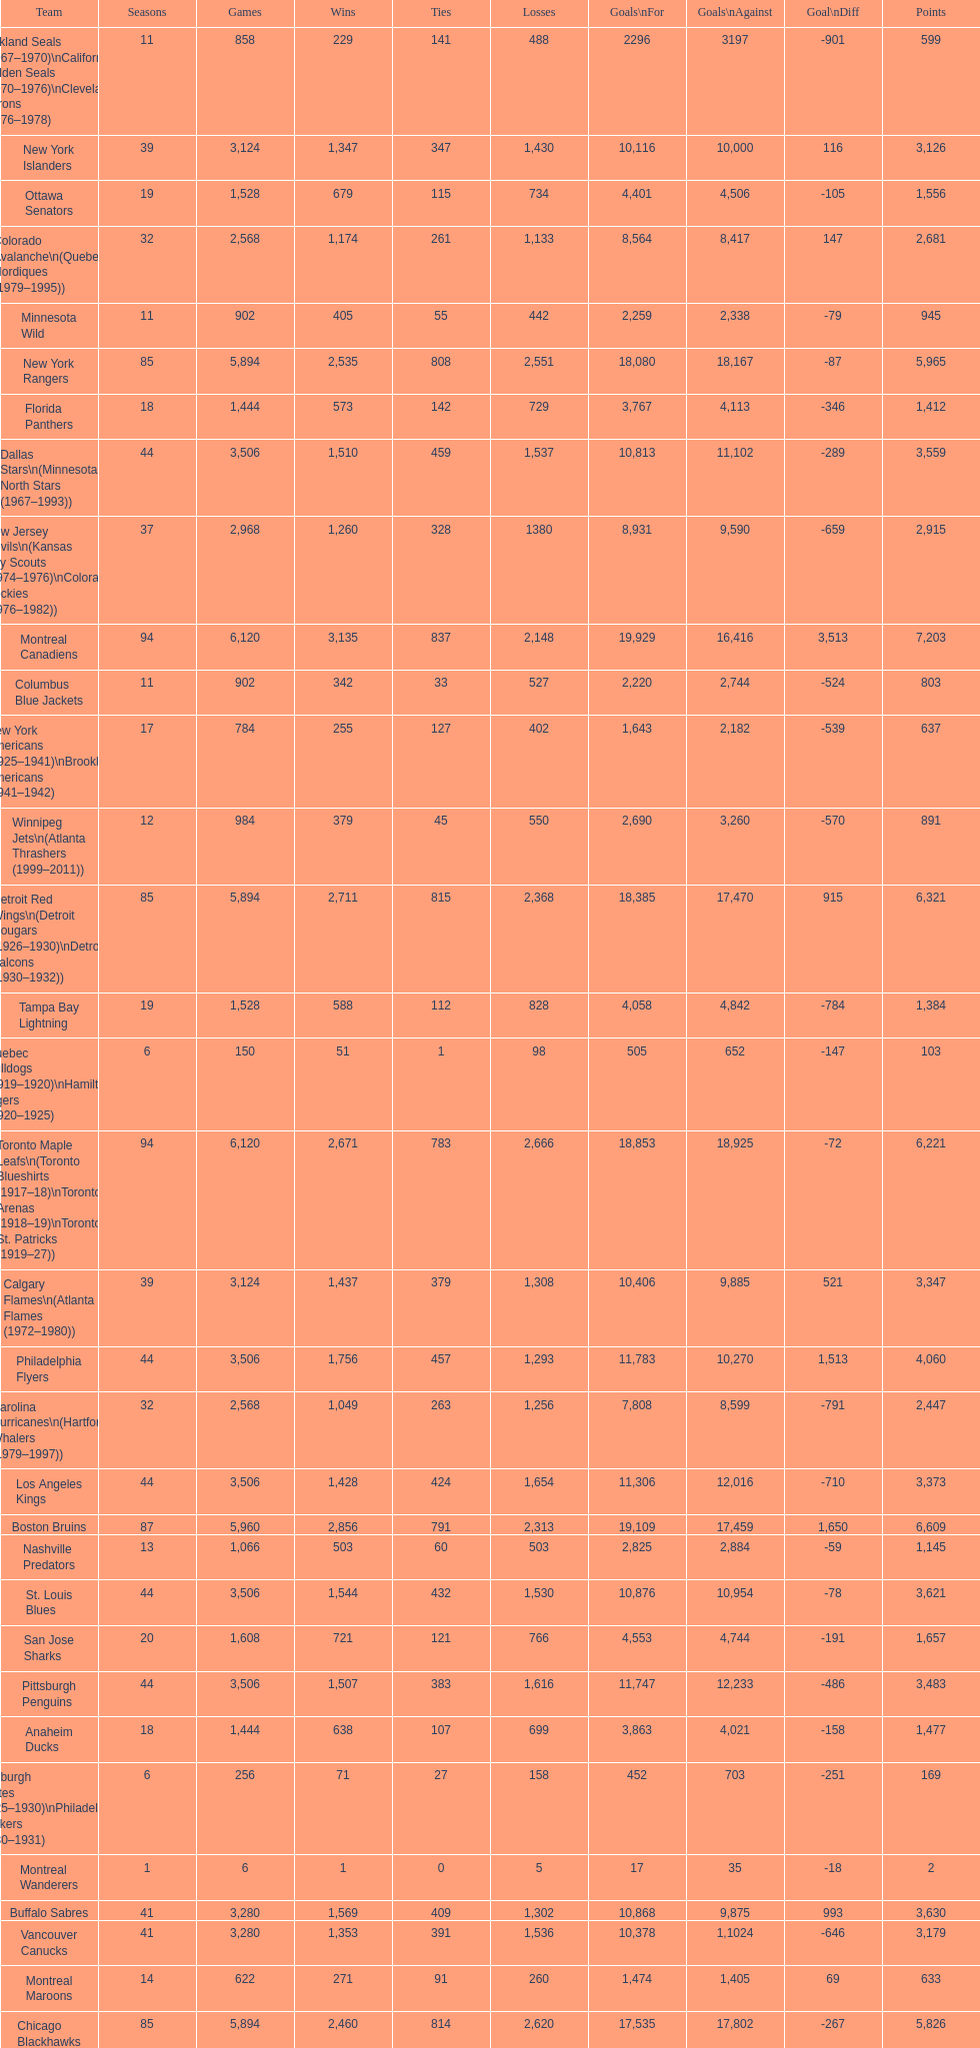Who has experienced the fewest losses? Montreal Wanderers. 